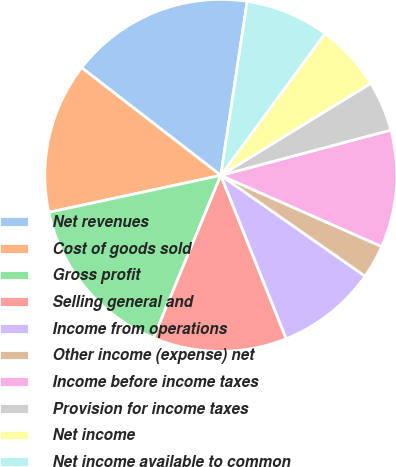<chart> <loc_0><loc_0><loc_500><loc_500><pie_chart><fcel>Net revenues<fcel>Cost of goods sold<fcel>Gross profit<fcel>Selling general and<fcel>Income from operations<fcel>Other income (expense) net<fcel>Income before income taxes<fcel>Provision for income taxes<fcel>Net income<fcel>Net income available to common<nl><fcel>16.92%<fcel>13.85%<fcel>15.38%<fcel>12.31%<fcel>9.23%<fcel>3.08%<fcel>10.77%<fcel>4.62%<fcel>6.15%<fcel>7.69%<nl></chart> 